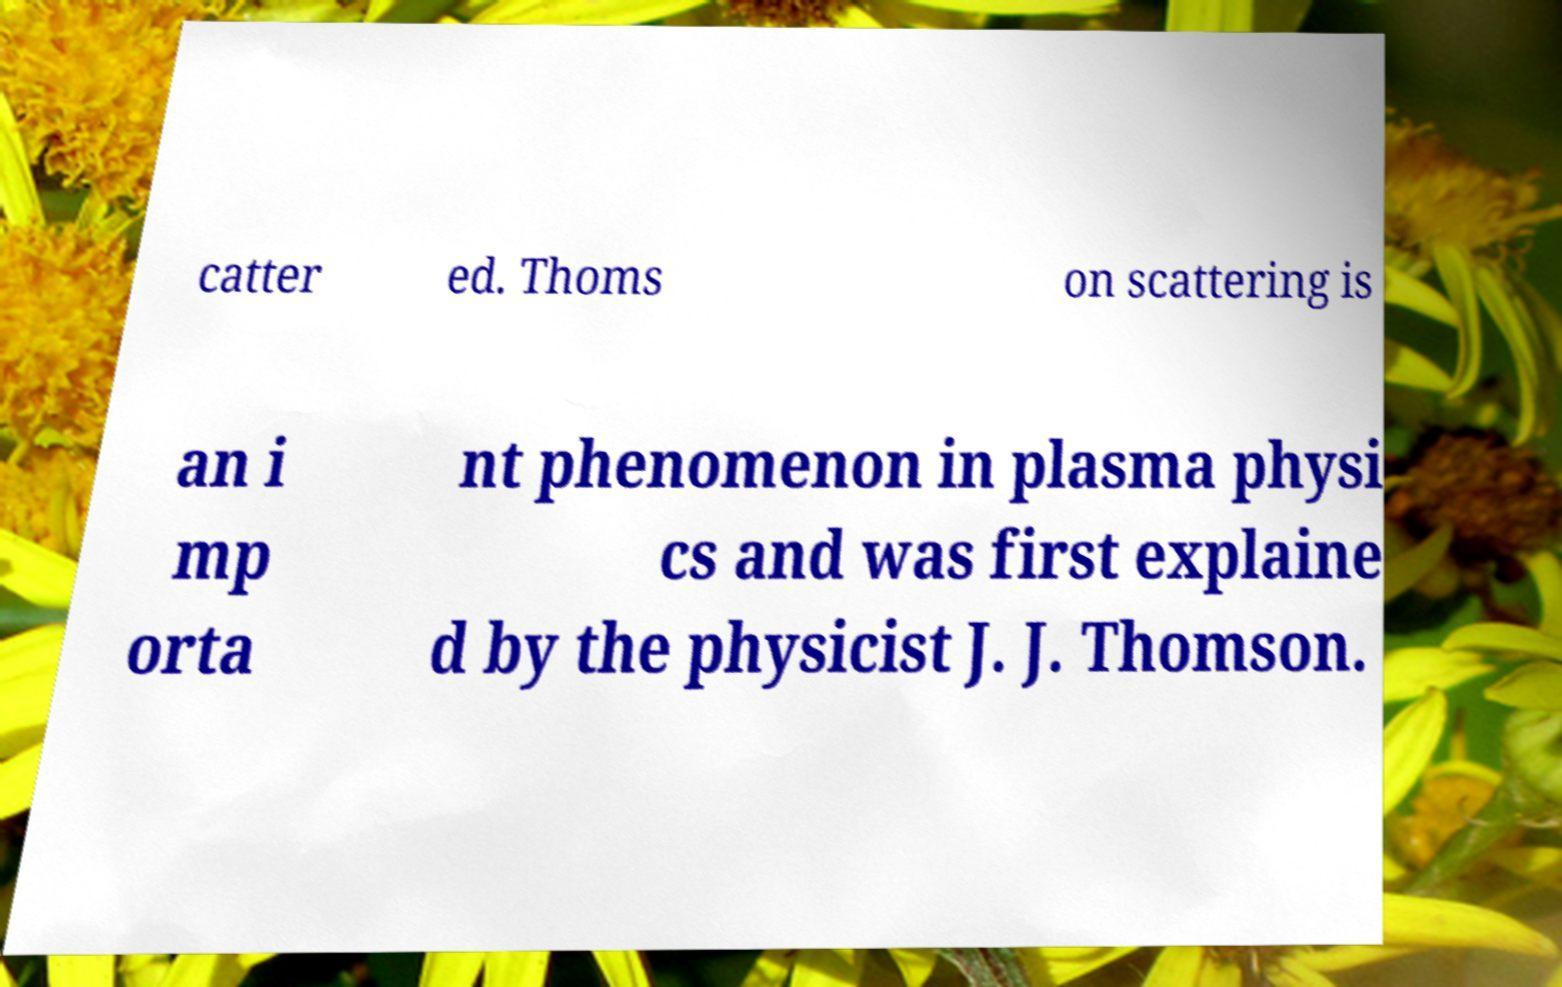Please read and relay the text visible in this image. What does it say? catter ed. Thoms on scattering is an i mp orta nt phenomenon in plasma physi cs and was first explaine d by the physicist J. J. Thomson. 